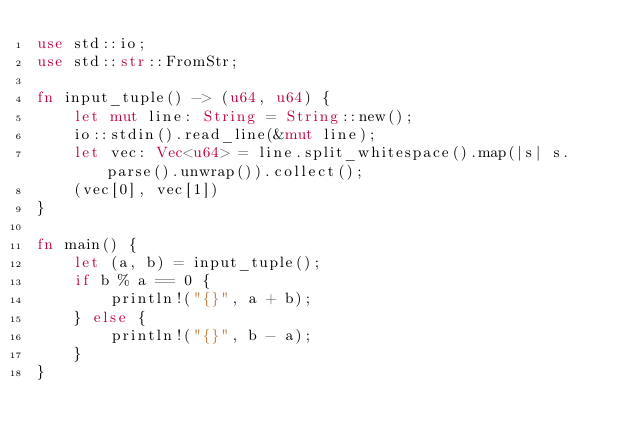Convert code to text. <code><loc_0><loc_0><loc_500><loc_500><_Rust_>use std::io;
use std::str::FromStr;

fn input_tuple() -> (u64, u64) {
    let mut line: String = String::new();
    io::stdin().read_line(&mut line);
    let vec: Vec<u64> = line.split_whitespace().map(|s| s.parse().unwrap()).collect();
    (vec[0], vec[1])
}

fn main() {
    let (a, b) = input_tuple();
    if b % a == 0 {
        println!("{}", a + b);
    } else {
        println!("{}", b - a);
    }
}</code> 